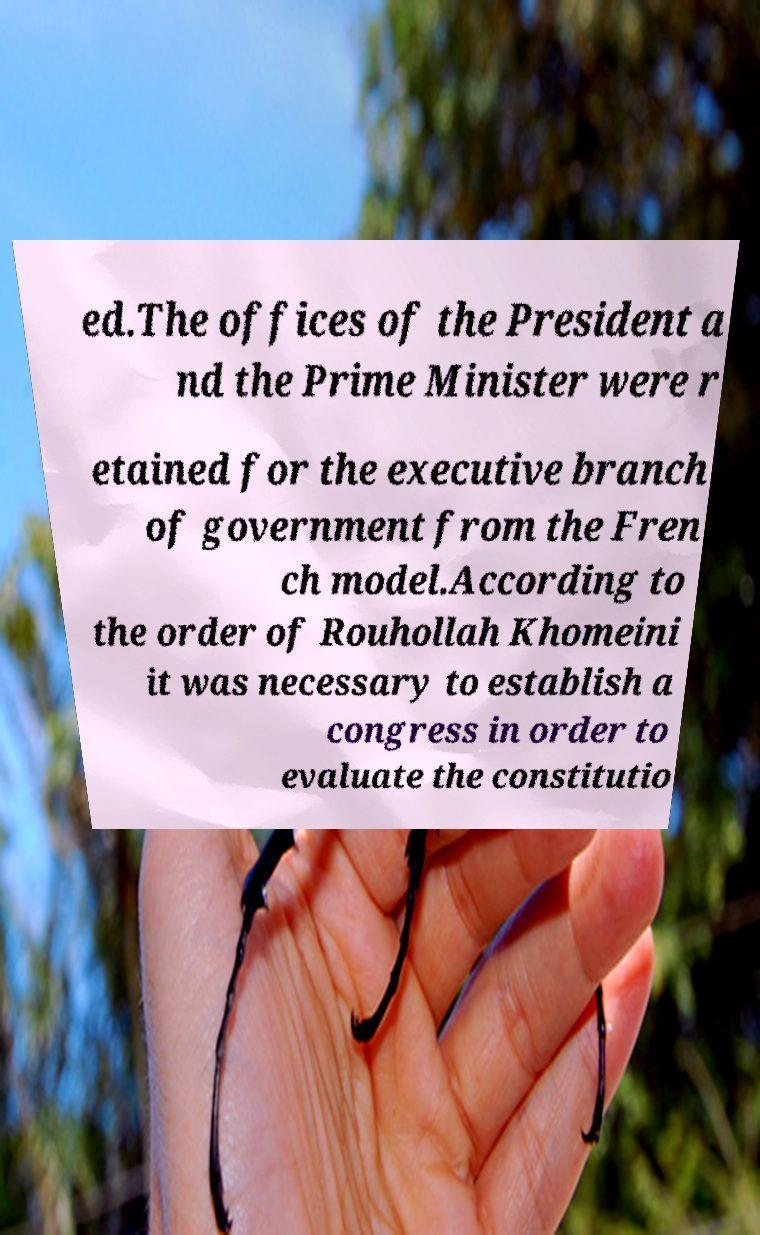Could you extract and type out the text from this image? ed.The offices of the President a nd the Prime Minister were r etained for the executive branch of government from the Fren ch model.According to the order of Rouhollah Khomeini it was necessary to establish a congress in order to evaluate the constitutio 